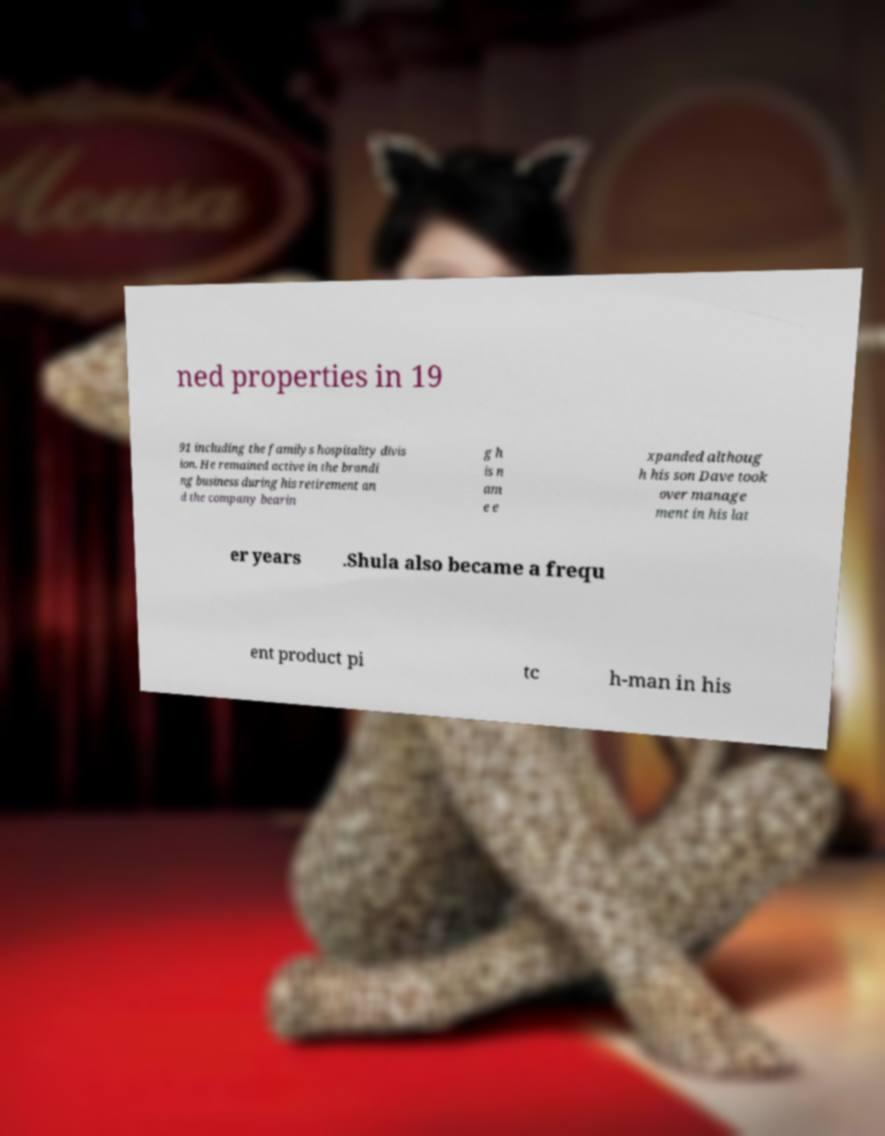What messages or text are displayed in this image? I need them in a readable, typed format. ned properties in 19 91 including the familys hospitality divis ion. He remained active in the brandi ng business during his retirement an d the company bearin g h is n am e e xpanded althoug h his son Dave took over manage ment in his lat er years .Shula also became a frequ ent product pi tc h-man in his 